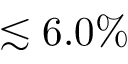<formula> <loc_0><loc_0><loc_500><loc_500>\lesssim 6 . 0 \%</formula> 